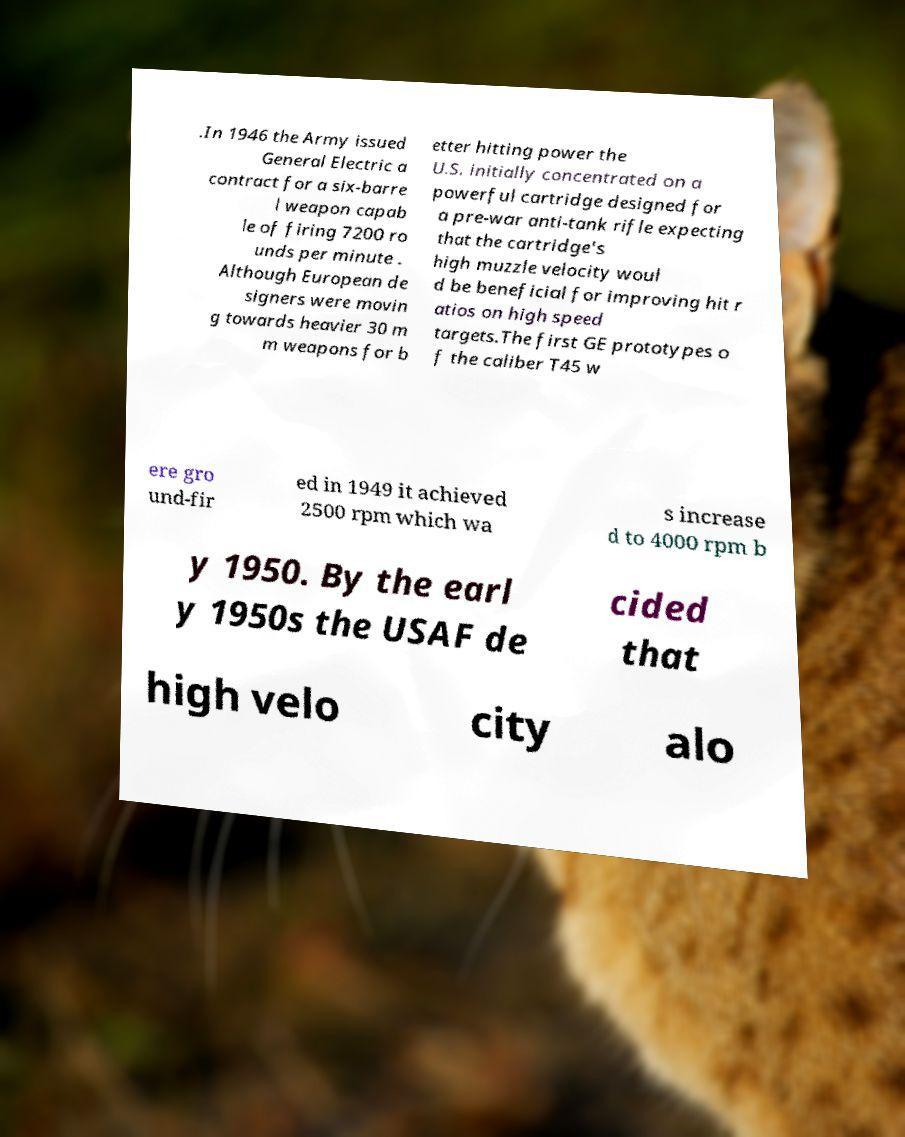What messages or text are displayed in this image? I need them in a readable, typed format. .In 1946 the Army issued General Electric a contract for a six-barre l weapon capab le of firing 7200 ro unds per minute . Although European de signers were movin g towards heavier 30 m m weapons for b etter hitting power the U.S. initially concentrated on a powerful cartridge designed for a pre-war anti-tank rifle expecting that the cartridge's high muzzle velocity woul d be beneficial for improving hit r atios on high speed targets.The first GE prototypes o f the caliber T45 w ere gro und-fir ed in 1949 it achieved 2500 rpm which wa s increase d to 4000 rpm b y 1950. By the earl y 1950s the USAF de cided that high velo city alo 